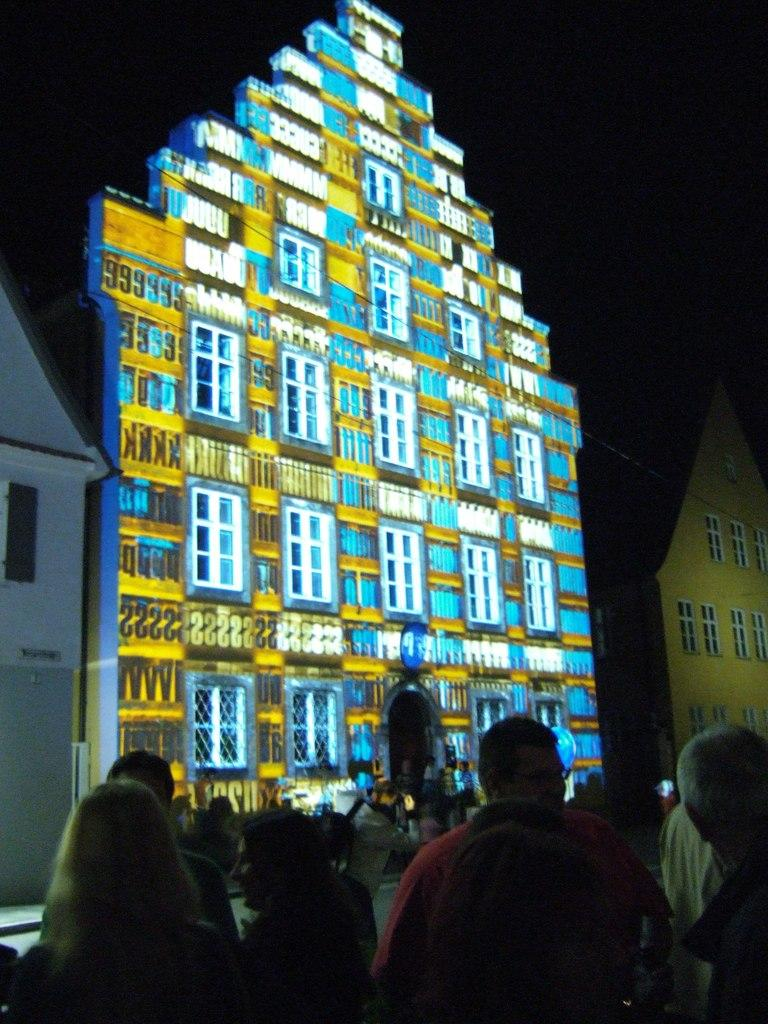What is the main subject of the image? The main subject of the image is a group of people. How can you describe the appearance of the people in the image? The people are wearing different color dresses. What can be seen in the background of the image? There are many buildings with windows in the background of the image. What is the color of the background in the image? The background of the image is black. How many plates are visible in the image? There are no plates present in the image. Can you hear the people in the image crying? There is no indication of crying in the image, and we cannot hear any sounds from the image. 